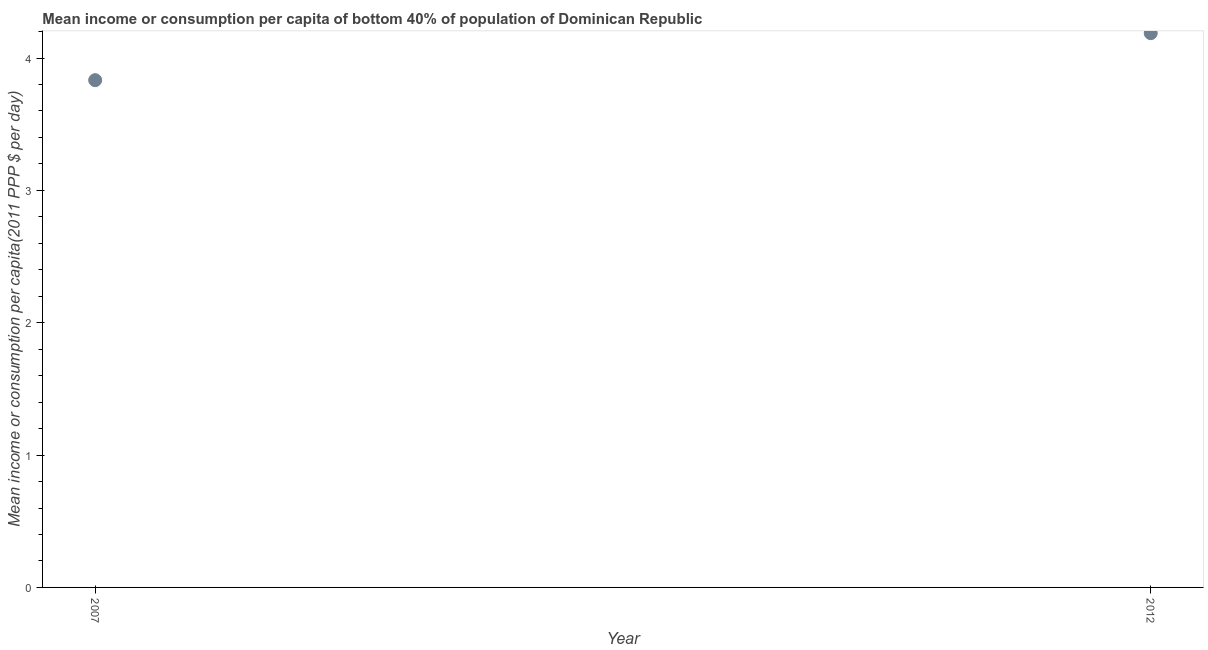What is the mean income or consumption in 2007?
Ensure brevity in your answer.  3.83. Across all years, what is the maximum mean income or consumption?
Your response must be concise. 4.19. Across all years, what is the minimum mean income or consumption?
Offer a very short reply. 3.83. In which year was the mean income or consumption minimum?
Your response must be concise. 2007. What is the sum of the mean income or consumption?
Offer a very short reply. 8.02. What is the difference between the mean income or consumption in 2007 and 2012?
Offer a very short reply. -0.36. What is the average mean income or consumption per year?
Your response must be concise. 4.01. What is the median mean income or consumption?
Make the answer very short. 4.01. In how many years, is the mean income or consumption greater than 2.6 $?
Ensure brevity in your answer.  2. Do a majority of the years between 2012 and 2007 (inclusive) have mean income or consumption greater than 1.6 $?
Make the answer very short. No. What is the ratio of the mean income or consumption in 2007 to that in 2012?
Keep it short and to the point. 0.92. Is the mean income or consumption in 2007 less than that in 2012?
Make the answer very short. Yes. In how many years, is the mean income or consumption greater than the average mean income or consumption taken over all years?
Your response must be concise. 1. How many dotlines are there?
Make the answer very short. 1. Does the graph contain any zero values?
Keep it short and to the point. No. What is the title of the graph?
Your answer should be compact. Mean income or consumption per capita of bottom 40% of population of Dominican Republic. What is the label or title of the Y-axis?
Your answer should be very brief. Mean income or consumption per capita(2011 PPP $ per day). What is the Mean income or consumption per capita(2011 PPP $ per day) in 2007?
Your answer should be very brief. 3.83. What is the Mean income or consumption per capita(2011 PPP $ per day) in 2012?
Provide a short and direct response. 4.19. What is the difference between the Mean income or consumption per capita(2011 PPP $ per day) in 2007 and 2012?
Your response must be concise. -0.36. What is the ratio of the Mean income or consumption per capita(2011 PPP $ per day) in 2007 to that in 2012?
Offer a terse response. 0.92. 